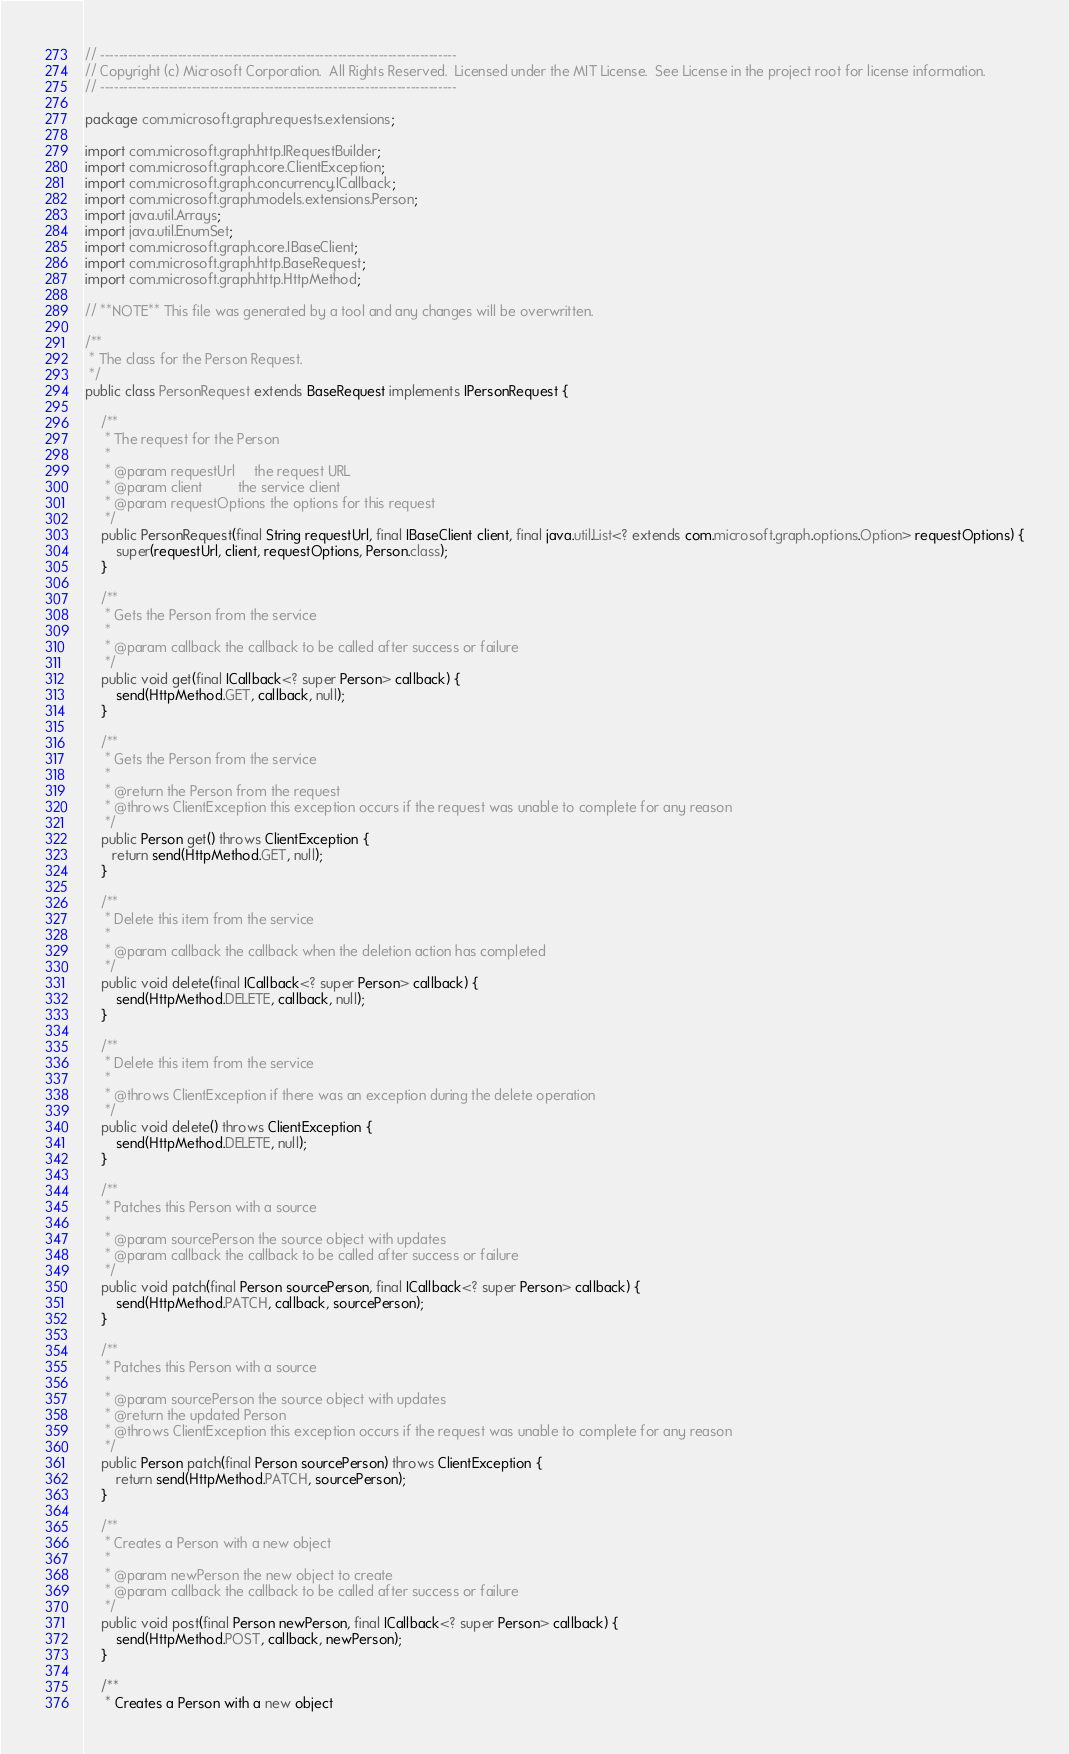<code> <loc_0><loc_0><loc_500><loc_500><_Java_>// ------------------------------------------------------------------------------
// Copyright (c) Microsoft Corporation.  All Rights Reserved.  Licensed under the MIT License.  See License in the project root for license information.
// ------------------------------------------------------------------------------

package com.microsoft.graph.requests.extensions;

import com.microsoft.graph.http.IRequestBuilder;
import com.microsoft.graph.core.ClientException;
import com.microsoft.graph.concurrency.ICallback;
import com.microsoft.graph.models.extensions.Person;
import java.util.Arrays;
import java.util.EnumSet;
import com.microsoft.graph.core.IBaseClient;
import com.microsoft.graph.http.BaseRequest;
import com.microsoft.graph.http.HttpMethod;

// **NOTE** This file was generated by a tool and any changes will be overwritten.

/**
 * The class for the Person Request.
 */
public class PersonRequest extends BaseRequest implements IPersonRequest {
	
    /**
     * The request for the Person
     *
     * @param requestUrl     the request URL
     * @param client         the service client
     * @param requestOptions the options for this request
     */
    public PersonRequest(final String requestUrl, final IBaseClient client, final java.util.List<? extends com.microsoft.graph.options.Option> requestOptions) {
        super(requestUrl, client, requestOptions, Person.class);
    }

    /**
     * Gets the Person from the service
     *
     * @param callback the callback to be called after success or failure
     */
    public void get(final ICallback<? super Person> callback) {
        send(HttpMethod.GET, callback, null);
    }

    /**
     * Gets the Person from the service
     *
     * @return the Person from the request
     * @throws ClientException this exception occurs if the request was unable to complete for any reason
     */
    public Person get() throws ClientException {
       return send(HttpMethod.GET, null);
    }

    /**
     * Delete this item from the service
     *
     * @param callback the callback when the deletion action has completed
     */
    public void delete(final ICallback<? super Person> callback) {
        send(HttpMethod.DELETE, callback, null);
    }

    /**
     * Delete this item from the service
     *
     * @throws ClientException if there was an exception during the delete operation
     */
    public void delete() throws ClientException {
        send(HttpMethod.DELETE, null);
    }

    /**
     * Patches this Person with a source
     *
     * @param sourcePerson the source object with updates
     * @param callback the callback to be called after success or failure
     */
    public void patch(final Person sourcePerson, final ICallback<? super Person> callback) {
        send(HttpMethod.PATCH, callback, sourcePerson);
    }

    /**
     * Patches this Person with a source
     *
     * @param sourcePerson the source object with updates
     * @return the updated Person
     * @throws ClientException this exception occurs if the request was unable to complete for any reason
     */
    public Person patch(final Person sourcePerson) throws ClientException {
        return send(HttpMethod.PATCH, sourcePerson);
    }

    /**
     * Creates a Person with a new object
     *
     * @param newPerson the new object to create
     * @param callback the callback to be called after success or failure
     */
    public void post(final Person newPerson, final ICallback<? super Person> callback) {
        send(HttpMethod.POST, callback, newPerson);
    }

    /**
     * Creates a Person with a new object</code> 